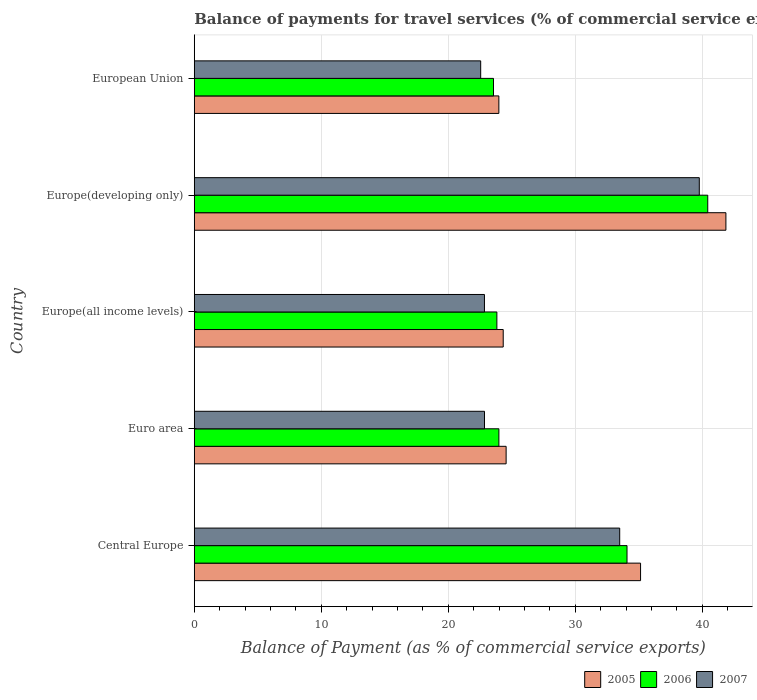How many different coloured bars are there?
Keep it short and to the point. 3. How many groups of bars are there?
Your answer should be compact. 5. How many bars are there on the 4th tick from the bottom?
Provide a short and direct response. 3. What is the label of the 2nd group of bars from the top?
Make the answer very short. Europe(developing only). In how many cases, is the number of bars for a given country not equal to the number of legend labels?
Your response must be concise. 0. What is the balance of payments for travel services in 2005 in Euro area?
Give a very brief answer. 24.56. Across all countries, what is the maximum balance of payments for travel services in 2005?
Provide a short and direct response. 41.87. Across all countries, what is the minimum balance of payments for travel services in 2006?
Make the answer very short. 23.56. In which country was the balance of payments for travel services in 2007 maximum?
Give a very brief answer. Europe(developing only). What is the total balance of payments for travel services in 2007 in the graph?
Give a very brief answer. 141.53. What is the difference between the balance of payments for travel services in 2007 in Europe(all income levels) and that in Europe(developing only)?
Provide a succinct answer. -16.92. What is the difference between the balance of payments for travel services in 2006 in Europe(all income levels) and the balance of payments for travel services in 2005 in Europe(developing only)?
Make the answer very short. -18.04. What is the average balance of payments for travel services in 2006 per country?
Make the answer very short. 29.18. What is the difference between the balance of payments for travel services in 2005 and balance of payments for travel services in 2006 in Europe(developing only)?
Provide a short and direct response. 1.43. What is the ratio of the balance of payments for travel services in 2005 in Europe(all income levels) to that in European Union?
Provide a short and direct response. 1.01. What is the difference between the highest and the second highest balance of payments for travel services in 2006?
Your answer should be compact. 6.36. What is the difference between the highest and the lowest balance of payments for travel services in 2006?
Offer a terse response. 16.87. In how many countries, is the balance of payments for travel services in 2006 greater than the average balance of payments for travel services in 2006 taken over all countries?
Your answer should be very brief. 2. Is the sum of the balance of payments for travel services in 2007 in Euro area and Europe(all income levels) greater than the maximum balance of payments for travel services in 2006 across all countries?
Your response must be concise. Yes. What does the 2nd bar from the top in European Union represents?
Your answer should be compact. 2006. What does the 3rd bar from the bottom in Euro area represents?
Offer a very short reply. 2007. Is it the case that in every country, the sum of the balance of payments for travel services in 2006 and balance of payments for travel services in 2005 is greater than the balance of payments for travel services in 2007?
Give a very brief answer. Yes. What is the difference between two consecutive major ticks on the X-axis?
Offer a terse response. 10. Are the values on the major ticks of X-axis written in scientific E-notation?
Your answer should be compact. No. Does the graph contain any zero values?
Make the answer very short. No. Where does the legend appear in the graph?
Provide a short and direct response. Bottom right. How many legend labels are there?
Give a very brief answer. 3. What is the title of the graph?
Keep it short and to the point. Balance of payments for travel services (% of commercial service exports). Does "1964" appear as one of the legend labels in the graph?
Your answer should be very brief. No. What is the label or title of the X-axis?
Your answer should be very brief. Balance of Payment (as % of commercial service exports). What is the label or title of the Y-axis?
Your answer should be compact. Country. What is the Balance of Payment (as % of commercial service exports) of 2005 in Central Europe?
Provide a succinct answer. 35.14. What is the Balance of Payment (as % of commercial service exports) of 2006 in Central Europe?
Ensure brevity in your answer.  34.08. What is the Balance of Payment (as % of commercial service exports) in 2007 in Central Europe?
Give a very brief answer. 33.5. What is the Balance of Payment (as % of commercial service exports) of 2005 in Euro area?
Provide a succinct answer. 24.56. What is the Balance of Payment (as % of commercial service exports) in 2006 in Euro area?
Make the answer very short. 23.99. What is the Balance of Payment (as % of commercial service exports) in 2007 in Euro area?
Make the answer very short. 22.86. What is the Balance of Payment (as % of commercial service exports) of 2005 in Europe(all income levels)?
Keep it short and to the point. 24.33. What is the Balance of Payment (as % of commercial service exports) of 2006 in Europe(all income levels)?
Your answer should be compact. 23.83. What is the Balance of Payment (as % of commercial service exports) in 2007 in Europe(all income levels)?
Ensure brevity in your answer.  22.85. What is the Balance of Payment (as % of commercial service exports) in 2005 in Europe(developing only)?
Your answer should be very brief. 41.87. What is the Balance of Payment (as % of commercial service exports) of 2006 in Europe(developing only)?
Your answer should be compact. 40.43. What is the Balance of Payment (as % of commercial service exports) of 2007 in Europe(developing only)?
Ensure brevity in your answer.  39.77. What is the Balance of Payment (as % of commercial service exports) in 2005 in European Union?
Your response must be concise. 23.99. What is the Balance of Payment (as % of commercial service exports) in 2006 in European Union?
Your answer should be very brief. 23.56. What is the Balance of Payment (as % of commercial service exports) of 2007 in European Union?
Keep it short and to the point. 22.56. Across all countries, what is the maximum Balance of Payment (as % of commercial service exports) of 2005?
Your answer should be compact. 41.87. Across all countries, what is the maximum Balance of Payment (as % of commercial service exports) of 2006?
Offer a very short reply. 40.43. Across all countries, what is the maximum Balance of Payment (as % of commercial service exports) in 2007?
Give a very brief answer. 39.77. Across all countries, what is the minimum Balance of Payment (as % of commercial service exports) of 2005?
Give a very brief answer. 23.99. Across all countries, what is the minimum Balance of Payment (as % of commercial service exports) in 2006?
Provide a short and direct response. 23.56. Across all countries, what is the minimum Balance of Payment (as % of commercial service exports) in 2007?
Your answer should be compact. 22.56. What is the total Balance of Payment (as % of commercial service exports) of 2005 in the graph?
Your answer should be very brief. 149.88. What is the total Balance of Payment (as % of commercial service exports) in 2006 in the graph?
Your response must be concise. 145.89. What is the total Balance of Payment (as % of commercial service exports) of 2007 in the graph?
Your answer should be compact. 141.53. What is the difference between the Balance of Payment (as % of commercial service exports) of 2005 in Central Europe and that in Euro area?
Ensure brevity in your answer.  10.59. What is the difference between the Balance of Payment (as % of commercial service exports) of 2006 in Central Europe and that in Euro area?
Ensure brevity in your answer.  10.09. What is the difference between the Balance of Payment (as % of commercial service exports) in 2007 in Central Europe and that in Euro area?
Offer a terse response. 10.65. What is the difference between the Balance of Payment (as % of commercial service exports) in 2005 in Central Europe and that in Europe(all income levels)?
Ensure brevity in your answer.  10.81. What is the difference between the Balance of Payment (as % of commercial service exports) in 2006 in Central Europe and that in Europe(all income levels)?
Offer a very short reply. 10.25. What is the difference between the Balance of Payment (as % of commercial service exports) of 2007 in Central Europe and that in Europe(all income levels)?
Offer a terse response. 10.65. What is the difference between the Balance of Payment (as % of commercial service exports) of 2005 in Central Europe and that in Europe(developing only)?
Your answer should be very brief. -6.72. What is the difference between the Balance of Payment (as % of commercial service exports) of 2006 in Central Europe and that in Europe(developing only)?
Provide a short and direct response. -6.36. What is the difference between the Balance of Payment (as % of commercial service exports) in 2007 in Central Europe and that in Europe(developing only)?
Ensure brevity in your answer.  -6.27. What is the difference between the Balance of Payment (as % of commercial service exports) in 2005 in Central Europe and that in European Union?
Provide a succinct answer. 11.16. What is the difference between the Balance of Payment (as % of commercial service exports) of 2006 in Central Europe and that in European Union?
Ensure brevity in your answer.  10.51. What is the difference between the Balance of Payment (as % of commercial service exports) of 2007 in Central Europe and that in European Union?
Offer a very short reply. 10.95. What is the difference between the Balance of Payment (as % of commercial service exports) of 2005 in Euro area and that in Europe(all income levels)?
Give a very brief answer. 0.23. What is the difference between the Balance of Payment (as % of commercial service exports) of 2006 in Euro area and that in Europe(all income levels)?
Your answer should be compact. 0.16. What is the difference between the Balance of Payment (as % of commercial service exports) of 2007 in Euro area and that in Europe(all income levels)?
Your answer should be compact. 0. What is the difference between the Balance of Payment (as % of commercial service exports) of 2005 in Euro area and that in Europe(developing only)?
Give a very brief answer. -17.31. What is the difference between the Balance of Payment (as % of commercial service exports) in 2006 in Euro area and that in Europe(developing only)?
Offer a very short reply. -16.45. What is the difference between the Balance of Payment (as % of commercial service exports) of 2007 in Euro area and that in Europe(developing only)?
Provide a short and direct response. -16.91. What is the difference between the Balance of Payment (as % of commercial service exports) of 2005 in Euro area and that in European Union?
Your response must be concise. 0.57. What is the difference between the Balance of Payment (as % of commercial service exports) in 2006 in Euro area and that in European Union?
Keep it short and to the point. 0.42. What is the difference between the Balance of Payment (as % of commercial service exports) of 2007 in Euro area and that in European Union?
Provide a succinct answer. 0.3. What is the difference between the Balance of Payment (as % of commercial service exports) in 2005 in Europe(all income levels) and that in Europe(developing only)?
Provide a short and direct response. -17.54. What is the difference between the Balance of Payment (as % of commercial service exports) in 2006 in Europe(all income levels) and that in Europe(developing only)?
Offer a terse response. -16.61. What is the difference between the Balance of Payment (as % of commercial service exports) of 2007 in Europe(all income levels) and that in Europe(developing only)?
Give a very brief answer. -16.92. What is the difference between the Balance of Payment (as % of commercial service exports) of 2005 in Europe(all income levels) and that in European Union?
Ensure brevity in your answer.  0.34. What is the difference between the Balance of Payment (as % of commercial service exports) of 2006 in Europe(all income levels) and that in European Union?
Your response must be concise. 0.27. What is the difference between the Balance of Payment (as % of commercial service exports) in 2007 in Europe(all income levels) and that in European Union?
Your response must be concise. 0.3. What is the difference between the Balance of Payment (as % of commercial service exports) of 2005 in Europe(developing only) and that in European Union?
Offer a very short reply. 17.88. What is the difference between the Balance of Payment (as % of commercial service exports) in 2006 in Europe(developing only) and that in European Union?
Your answer should be compact. 16.87. What is the difference between the Balance of Payment (as % of commercial service exports) of 2007 in Europe(developing only) and that in European Union?
Provide a succinct answer. 17.21. What is the difference between the Balance of Payment (as % of commercial service exports) of 2005 in Central Europe and the Balance of Payment (as % of commercial service exports) of 2006 in Euro area?
Keep it short and to the point. 11.16. What is the difference between the Balance of Payment (as % of commercial service exports) of 2005 in Central Europe and the Balance of Payment (as % of commercial service exports) of 2007 in Euro area?
Offer a terse response. 12.29. What is the difference between the Balance of Payment (as % of commercial service exports) in 2006 in Central Europe and the Balance of Payment (as % of commercial service exports) in 2007 in Euro area?
Your answer should be very brief. 11.22. What is the difference between the Balance of Payment (as % of commercial service exports) of 2005 in Central Europe and the Balance of Payment (as % of commercial service exports) of 2006 in Europe(all income levels)?
Make the answer very short. 11.31. What is the difference between the Balance of Payment (as % of commercial service exports) in 2005 in Central Europe and the Balance of Payment (as % of commercial service exports) in 2007 in Europe(all income levels)?
Your answer should be compact. 12.29. What is the difference between the Balance of Payment (as % of commercial service exports) in 2006 in Central Europe and the Balance of Payment (as % of commercial service exports) in 2007 in Europe(all income levels)?
Your answer should be compact. 11.23. What is the difference between the Balance of Payment (as % of commercial service exports) in 2005 in Central Europe and the Balance of Payment (as % of commercial service exports) in 2006 in Europe(developing only)?
Your answer should be compact. -5.29. What is the difference between the Balance of Payment (as % of commercial service exports) of 2005 in Central Europe and the Balance of Payment (as % of commercial service exports) of 2007 in Europe(developing only)?
Offer a very short reply. -4.63. What is the difference between the Balance of Payment (as % of commercial service exports) of 2006 in Central Europe and the Balance of Payment (as % of commercial service exports) of 2007 in Europe(developing only)?
Make the answer very short. -5.69. What is the difference between the Balance of Payment (as % of commercial service exports) of 2005 in Central Europe and the Balance of Payment (as % of commercial service exports) of 2006 in European Union?
Keep it short and to the point. 11.58. What is the difference between the Balance of Payment (as % of commercial service exports) of 2005 in Central Europe and the Balance of Payment (as % of commercial service exports) of 2007 in European Union?
Offer a terse response. 12.59. What is the difference between the Balance of Payment (as % of commercial service exports) in 2006 in Central Europe and the Balance of Payment (as % of commercial service exports) in 2007 in European Union?
Ensure brevity in your answer.  11.52. What is the difference between the Balance of Payment (as % of commercial service exports) of 2005 in Euro area and the Balance of Payment (as % of commercial service exports) of 2006 in Europe(all income levels)?
Ensure brevity in your answer.  0.73. What is the difference between the Balance of Payment (as % of commercial service exports) in 2005 in Euro area and the Balance of Payment (as % of commercial service exports) in 2007 in Europe(all income levels)?
Offer a terse response. 1.71. What is the difference between the Balance of Payment (as % of commercial service exports) in 2006 in Euro area and the Balance of Payment (as % of commercial service exports) in 2007 in Europe(all income levels)?
Your answer should be very brief. 1.14. What is the difference between the Balance of Payment (as % of commercial service exports) of 2005 in Euro area and the Balance of Payment (as % of commercial service exports) of 2006 in Europe(developing only)?
Keep it short and to the point. -15.88. What is the difference between the Balance of Payment (as % of commercial service exports) in 2005 in Euro area and the Balance of Payment (as % of commercial service exports) in 2007 in Europe(developing only)?
Offer a terse response. -15.21. What is the difference between the Balance of Payment (as % of commercial service exports) in 2006 in Euro area and the Balance of Payment (as % of commercial service exports) in 2007 in Europe(developing only)?
Provide a short and direct response. -15.78. What is the difference between the Balance of Payment (as % of commercial service exports) of 2005 in Euro area and the Balance of Payment (as % of commercial service exports) of 2007 in European Union?
Ensure brevity in your answer.  2. What is the difference between the Balance of Payment (as % of commercial service exports) of 2006 in Euro area and the Balance of Payment (as % of commercial service exports) of 2007 in European Union?
Ensure brevity in your answer.  1.43. What is the difference between the Balance of Payment (as % of commercial service exports) of 2005 in Europe(all income levels) and the Balance of Payment (as % of commercial service exports) of 2006 in Europe(developing only)?
Your answer should be very brief. -16.11. What is the difference between the Balance of Payment (as % of commercial service exports) of 2005 in Europe(all income levels) and the Balance of Payment (as % of commercial service exports) of 2007 in Europe(developing only)?
Give a very brief answer. -15.44. What is the difference between the Balance of Payment (as % of commercial service exports) of 2006 in Europe(all income levels) and the Balance of Payment (as % of commercial service exports) of 2007 in Europe(developing only)?
Offer a terse response. -15.94. What is the difference between the Balance of Payment (as % of commercial service exports) in 2005 in Europe(all income levels) and the Balance of Payment (as % of commercial service exports) in 2006 in European Union?
Offer a very short reply. 0.77. What is the difference between the Balance of Payment (as % of commercial service exports) of 2005 in Europe(all income levels) and the Balance of Payment (as % of commercial service exports) of 2007 in European Union?
Keep it short and to the point. 1.77. What is the difference between the Balance of Payment (as % of commercial service exports) of 2006 in Europe(all income levels) and the Balance of Payment (as % of commercial service exports) of 2007 in European Union?
Make the answer very short. 1.27. What is the difference between the Balance of Payment (as % of commercial service exports) of 2005 in Europe(developing only) and the Balance of Payment (as % of commercial service exports) of 2006 in European Union?
Your response must be concise. 18.3. What is the difference between the Balance of Payment (as % of commercial service exports) of 2005 in Europe(developing only) and the Balance of Payment (as % of commercial service exports) of 2007 in European Union?
Give a very brief answer. 19.31. What is the difference between the Balance of Payment (as % of commercial service exports) in 2006 in Europe(developing only) and the Balance of Payment (as % of commercial service exports) in 2007 in European Union?
Make the answer very short. 17.88. What is the average Balance of Payment (as % of commercial service exports) in 2005 per country?
Give a very brief answer. 29.98. What is the average Balance of Payment (as % of commercial service exports) of 2006 per country?
Your response must be concise. 29.18. What is the average Balance of Payment (as % of commercial service exports) in 2007 per country?
Your answer should be compact. 28.31. What is the difference between the Balance of Payment (as % of commercial service exports) of 2005 and Balance of Payment (as % of commercial service exports) of 2006 in Central Europe?
Offer a very short reply. 1.07. What is the difference between the Balance of Payment (as % of commercial service exports) of 2005 and Balance of Payment (as % of commercial service exports) of 2007 in Central Europe?
Ensure brevity in your answer.  1.64. What is the difference between the Balance of Payment (as % of commercial service exports) of 2006 and Balance of Payment (as % of commercial service exports) of 2007 in Central Europe?
Provide a short and direct response. 0.58. What is the difference between the Balance of Payment (as % of commercial service exports) of 2005 and Balance of Payment (as % of commercial service exports) of 2006 in Euro area?
Give a very brief answer. 0.57. What is the difference between the Balance of Payment (as % of commercial service exports) of 2005 and Balance of Payment (as % of commercial service exports) of 2007 in Euro area?
Provide a short and direct response. 1.7. What is the difference between the Balance of Payment (as % of commercial service exports) in 2006 and Balance of Payment (as % of commercial service exports) in 2007 in Euro area?
Make the answer very short. 1.13. What is the difference between the Balance of Payment (as % of commercial service exports) in 2005 and Balance of Payment (as % of commercial service exports) in 2006 in Europe(all income levels)?
Ensure brevity in your answer.  0.5. What is the difference between the Balance of Payment (as % of commercial service exports) in 2005 and Balance of Payment (as % of commercial service exports) in 2007 in Europe(all income levels)?
Offer a very short reply. 1.48. What is the difference between the Balance of Payment (as % of commercial service exports) of 2006 and Balance of Payment (as % of commercial service exports) of 2007 in Europe(all income levels)?
Offer a terse response. 0.98. What is the difference between the Balance of Payment (as % of commercial service exports) of 2005 and Balance of Payment (as % of commercial service exports) of 2006 in Europe(developing only)?
Your response must be concise. 1.43. What is the difference between the Balance of Payment (as % of commercial service exports) in 2005 and Balance of Payment (as % of commercial service exports) in 2007 in Europe(developing only)?
Provide a short and direct response. 2.1. What is the difference between the Balance of Payment (as % of commercial service exports) of 2006 and Balance of Payment (as % of commercial service exports) of 2007 in Europe(developing only)?
Offer a very short reply. 0.67. What is the difference between the Balance of Payment (as % of commercial service exports) of 2005 and Balance of Payment (as % of commercial service exports) of 2006 in European Union?
Offer a very short reply. 0.42. What is the difference between the Balance of Payment (as % of commercial service exports) in 2005 and Balance of Payment (as % of commercial service exports) in 2007 in European Union?
Provide a short and direct response. 1.43. What is the difference between the Balance of Payment (as % of commercial service exports) in 2006 and Balance of Payment (as % of commercial service exports) in 2007 in European Union?
Ensure brevity in your answer.  1.01. What is the ratio of the Balance of Payment (as % of commercial service exports) in 2005 in Central Europe to that in Euro area?
Make the answer very short. 1.43. What is the ratio of the Balance of Payment (as % of commercial service exports) in 2006 in Central Europe to that in Euro area?
Offer a terse response. 1.42. What is the ratio of the Balance of Payment (as % of commercial service exports) in 2007 in Central Europe to that in Euro area?
Give a very brief answer. 1.47. What is the ratio of the Balance of Payment (as % of commercial service exports) in 2005 in Central Europe to that in Europe(all income levels)?
Your response must be concise. 1.44. What is the ratio of the Balance of Payment (as % of commercial service exports) of 2006 in Central Europe to that in Europe(all income levels)?
Provide a succinct answer. 1.43. What is the ratio of the Balance of Payment (as % of commercial service exports) of 2007 in Central Europe to that in Europe(all income levels)?
Offer a terse response. 1.47. What is the ratio of the Balance of Payment (as % of commercial service exports) in 2005 in Central Europe to that in Europe(developing only)?
Make the answer very short. 0.84. What is the ratio of the Balance of Payment (as % of commercial service exports) in 2006 in Central Europe to that in Europe(developing only)?
Your answer should be very brief. 0.84. What is the ratio of the Balance of Payment (as % of commercial service exports) of 2007 in Central Europe to that in Europe(developing only)?
Keep it short and to the point. 0.84. What is the ratio of the Balance of Payment (as % of commercial service exports) of 2005 in Central Europe to that in European Union?
Your response must be concise. 1.47. What is the ratio of the Balance of Payment (as % of commercial service exports) in 2006 in Central Europe to that in European Union?
Your answer should be very brief. 1.45. What is the ratio of the Balance of Payment (as % of commercial service exports) of 2007 in Central Europe to that in European Union?
Offer a very short reply. 1.49. What is the ratio of the Balance of Payment (as % of commercial service exports) of 2005 in Euro area to that in Europe(all income levels)?
Give a very brief answer. 1.01. What is the ratio of the Balance of Payment (as % of commercial service exports) in 2006 in Euro area to that in Europe(all income levels)?
Ensure brevity in your answer.  1.01. What is the ratio of the Balance of Payment (as % of commercial service exports) in 2005 in Euro area to that in Europe(developing only)?
Make the answer very short. 0.59. What is the ratio of the Balance of Payment (as % of commercial service exports) in 2006 in Euro area to that in Europe(developing only)?
Your answer should be very brief. 0.59. What is the ratio of the Balance of Payment (as % of commercial service exports) in 2007 in Euro area to that in Europe(developing only)?
Offer a very short reply. 0.57. What is the ratio of the Balance of Payment (as % of commercial service exports) in 2005 in Euro area to that in European Union?
Give a very brief answer. 1.02. What is the ratio of the Balance of Payment (as % of commercial service exports) in 2006 in Euro area to that in European Union?
Offer a terse response. 1.02. What is the ratio of the Balance of Payment (as % of commercial service exports) of 2007 in Euro area to that in European Union?
Offer a terse response. 1.01. What is the ratio of the Balance of Payment (as % of commercial service exports) in 2005 in Europe(all income levels) to that in Europe(developing only)?
Offer a terse response. 0.58. What is the ratio of the Balance of Payment (as % of commercial service exports) in 2006 in Europe(all income levels) to that in Europe(developing only)?
Offer a very short reply. 0.59. What is the ratio of the Balance of Payment (as % of commercial service exports) in 2007 in Europe(all income levels) to that in Europe(developing only)?
Your answer should be compact. 0.57. What is the ratio of the Balance of Payment (as % of commercial service exports) in 2005 in Europe(all income levels) to that in European Union?
Offer a very short reply. 1.01. What is the ratio of the Balance of Payment (as % of commercial service exports) in 2006 in Europe(all income levels) to that in European Union?
Make the answer very short. 1.01. What is the ratio of the Balance of Payment (as % of commercial service exports) of 2007 in Europe(all income levels) to that in European Union?
Make the answer very short. 1.01. What is the ratio of the Balance of Payment (as % of commercial service exports) of 2005 in Europe(developing only) to that in European Union?
Provide a short and direct response. 1.75. What is the ratio of the Balance of Payment (as % of commercial service exports) in 2006 in Europe(developing only) to that in European Union?
Ensure brevity in your answer.  1.72. What is the ratio of the Balance of Payment (as % of commercial service exports) of 2007 in Europe(developing only) to that in European Union?
Provide a short and direct response. 1.76. What is the difference between the highest and the second highest Balance of Payment (as % of commercial service exports) of 2005?
Provide a short and direct response. 6.72. What is the difference between the highest and the second highest Balance of Payment (as % of commercial service exports) of 2006?
Provide a short and direct response. 6.36. What is the difference between the highest and the second highest Balance of Payment (as % of commercial service exports) in 2007?
Offer a terse response. 6.27. What is the difference between the highest and the lowest Balance of Payment (as % of commercial service exports) of 2005?
Provide a succinct answer. 17.88. What is the difference between the highest and the lowest Balance of Payment (as % of commercial service exports) in 2006?
Keep it short and to the point. 16.87. What is the difference between the highest and the lowest Balance of Payment (as % of commercial service exports) in 2007?
Provide a succinct answer. 17.21. 